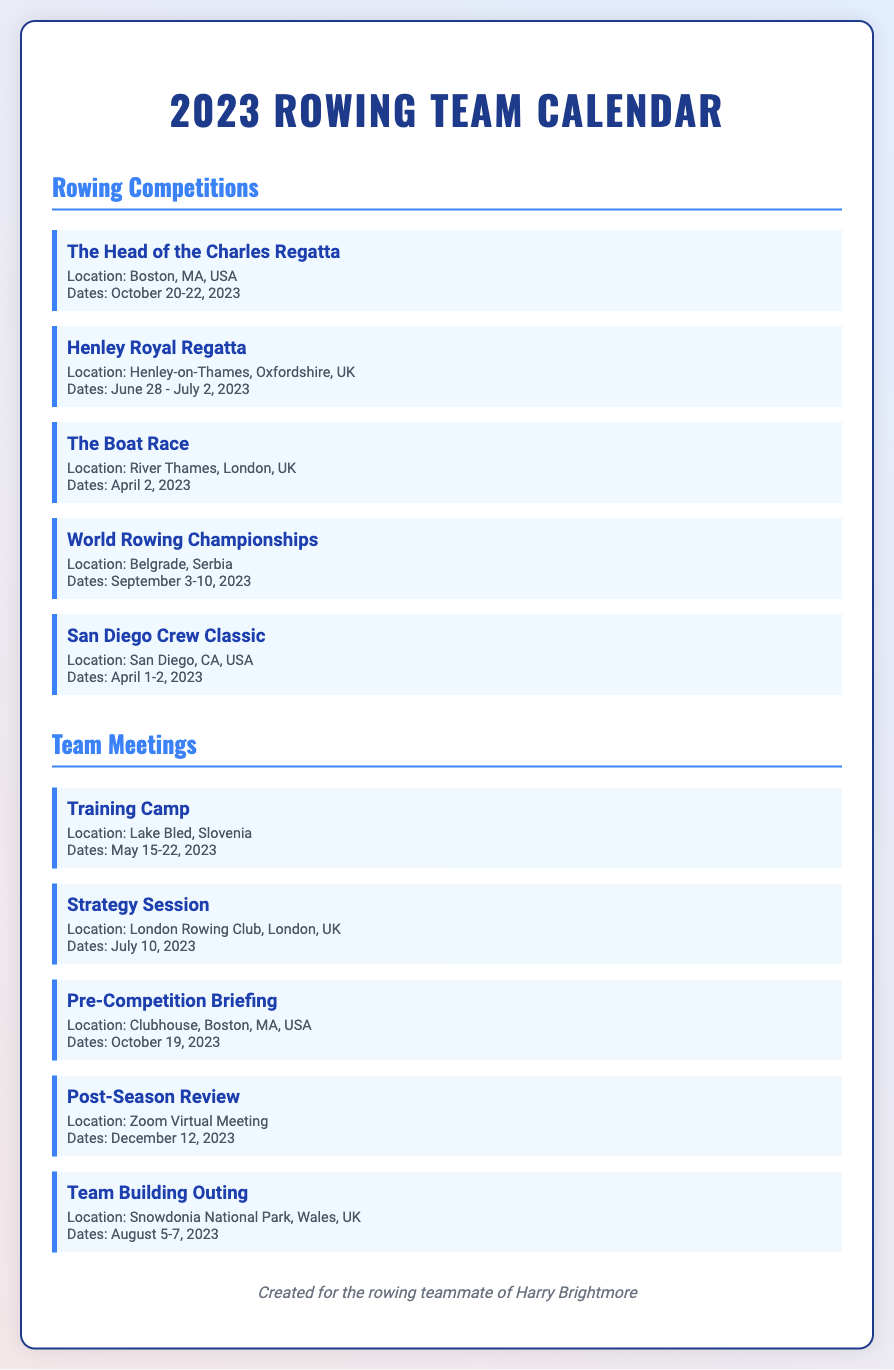What is the title of the document? The title of the document is prominently displayed at the top as the main heading.
Answer: 2023 Rowing Team Calendar When does the Head of the Charles Regatta take place? The date for this particular competition is clearly stated in the event details.
Answer: October 20-22, 2023 Where is the Henley Royal Regatta located? The location for the Henley Royal Regatta is mentioned in the event's description.
Answer: Henley-on-Thames, Oxfordshire, UK How many rowing competitions are listed? The number of competitions can be tallied from the listed events under "Rowing Competitions."
Answer: 5 Which event occurs on April 2, 2023? The date is specified for this specific rowing competition in the document.
Answer: The Boat Race What type of meeting is scheduled for October 19, 2023? This question requires understanding from the provided meeting entries.
Answer: Pre-Competition Briefing What location is mentioned for the Post-Season Review? The location for this team meeting is noted in the event details.
Answer: Zoom Virtual Meeting What is the date range for the Training Camp? The date range is clearly stated in the details of this team meeting.
Answer: May 15-22, 2023 